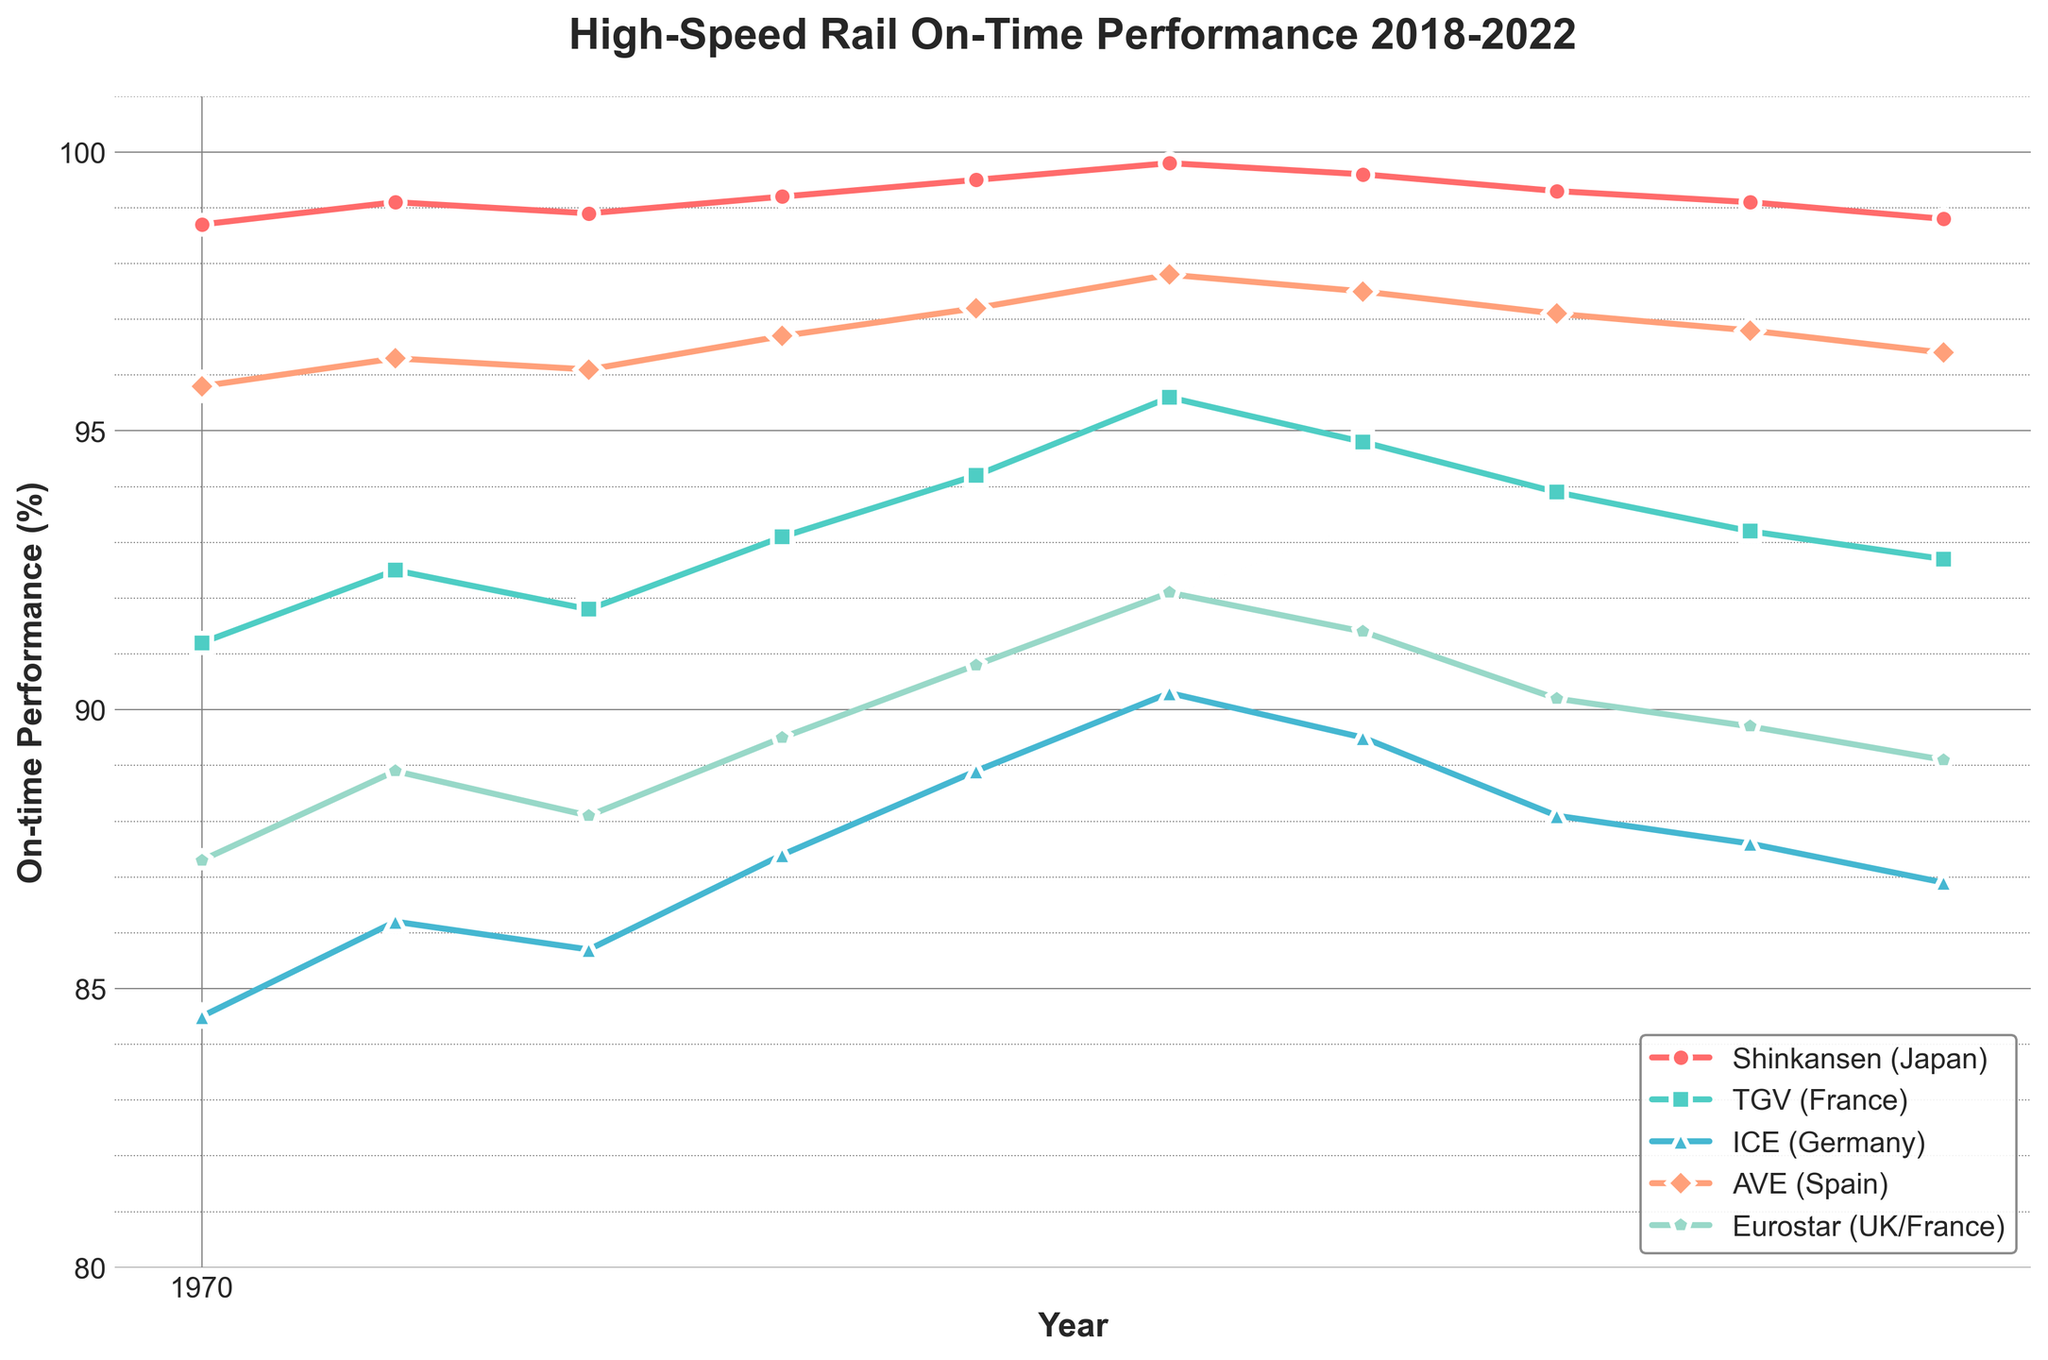What's the average on-time performance of the Shinkansen over the 5-year period? To find the average on-time performance of the Shinkansen, sum up all the values for the Shinkansen and divide by the number of data points. The values are 98.7 + 99.1 + 98.9 + 99.2 + 99.5 + 99.8 + 99.6 + 99.3 + 99.1 + 98.8, resulting in a sum of 990.0. There are 10 data points, so the average is 990.0 / 10 = 99.0.
Answer: 99.0 Which service has the highest on-time performance in 2020-07-01? Look at the performance values for all services on 2020-07-01. The values are Shinkansen: 99.8, TGV: 95.6, ICE: 90.3, AVE: 97.8, Eurostar: 92.1. The highest value is 99.8 for the Shinkansen.
Answer: Shinkansen How does the performance of the ICE in 2021-07-01 compare to the performance of the TGV in the same period? Look at the on-time performance values for the ICE and TGV in 2021-07-01. ICE: 88.1, TGV: 93.9. The TGV has a higher performance than the ICE.
Answer: TGV higher Which service had the most significant improvement from 2018-01-01 to 2020-07-01? Calculate the difference between 2020-07-01 and 2018-01-01 for all services. Shinkansen: 99.8 - 98.7 = 1.1, TGV: 95.6 - 91.2 = 4.4, ICE: 90.3 - 84.5 = 5.8, AVE: 97.8 - 95.8 = 2.0, Eurostar: 92.1 - 87.3 = 4.8. The ICE had the most significant improvement with 5.8.
Answer: ICE Between 2021-07-01 and 2022-07-01, which service saw a decline in performance, and by how much? Calculate the difference between 2022-07-01 and 2021-07-01 for all services. Shinkansen: 98.8 - 99.3 = -0.5, TGV: 92.7 - 93.9 = -1.2, ICE: 86.9 - 88.1 = -1.2, AVE: 96.4 - 97.1 = -0.7, Eurostar: 89.1 - 90.2 = -1.1. All services show a decline except for specific services where the decrease magnitude needs examining. The TGV and ICE show the same decline of -1.2.
Answer: TGV and ICE, -1.2 Which service consistently had the lowest on-time performance over the 5-year period? Evaluate the data for each service and note the lowest values across the period. ICE consistently has the lowest values compared to others, e.g., 84.5, 86.2, 85.7, 87.4, 88.9, 90.3, 89.5, 88.1, 87.6, and 86.9.
Answer: ICE On what date did the Eurostar achieve its highest on-time performance, and what was the value? Check all the performance values for Eurostar: 87.3, 88.9, 88.1, 89.5, 90.8, 92.1, 91.4, 90.2, 89.7, 89.1. The highest value is 92.1 on 2020-07-01.
Answer: 2020-07-01, 92.1 